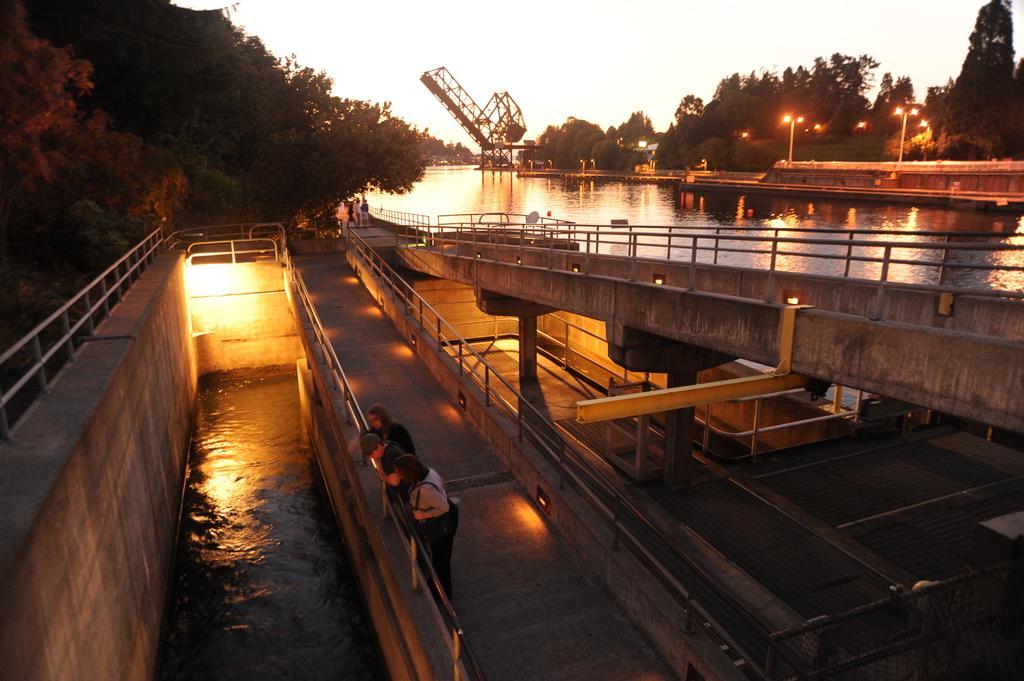Could you give a brief overview of what you see in this image? In this picture I can observe a river. There are three members standing behind the railing. On the right I can observe some lights fixed to the poles. In the background there are trees and a sky. 